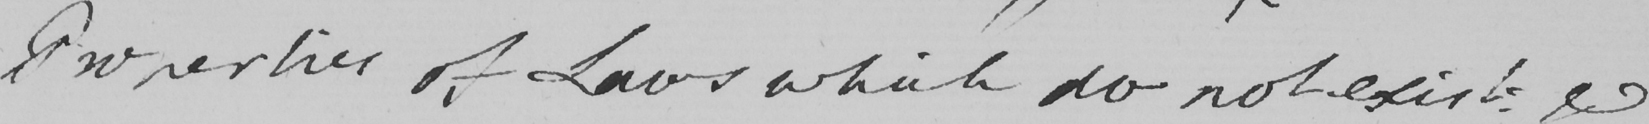What text is written in this handwritten line? Properties of Laws which do not exist & 